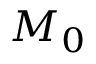Convert formula to latex. <formula><loc_0><loc_0><loc_500><loc_500>M _ { 0 }</formula> 